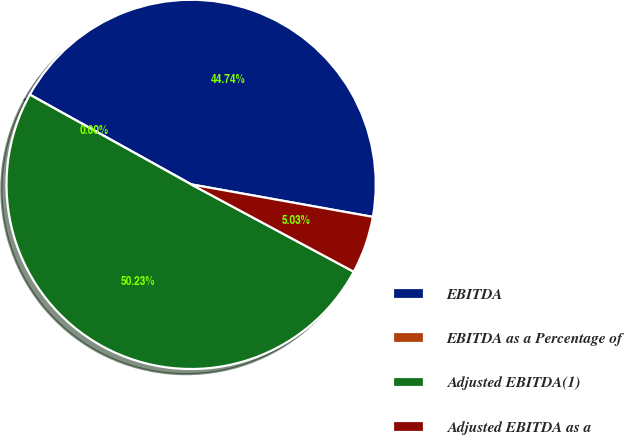<chart> <loc_0><loc_0><loc_500><loc_500><pie_chart><fcel>EBITDA<fcel>EBITDA as a Percentage of<fcel>Adjusted EBITDA(1)<fcel>Adjusted EBITDA as a<nl><fcel>44.74%<fcel>0.0%<fcel>50.23%<fcel>5.03%<nl></chart> 